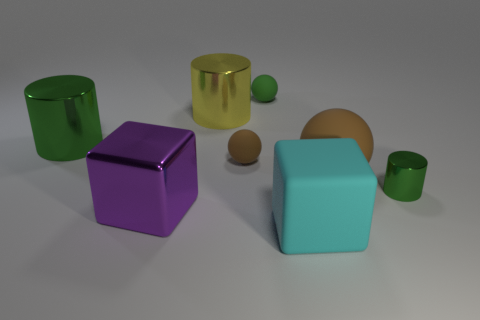Are any tiny purple shiny objects visible?
Give a very brief answer. No. How many tiny rubber spheres are the same color as the large ball?
Keep it short and to the point. 1. Are the large yellow cylinder and the object in front of the big shiny cube made of the same material?
Offer a terse response. No. Are there more green metal things in front of the big brown thing than big cyan cylinders?
Keep it short and to the point. Yes. There is a large rubber sphere; is it the same color as the small sphere that is in front of the large green cylinder?
Ensure brevity in your answer.  Yes. Are there an equal number of big brown balls behind the big brown matte object and green cylinders that are on the left side of the green ball?
Keep it short and to the point. No. There is a cylinder that is right of the big cyan object; what is its material?
Your response must be concise. Metal. What number of things are cylinders that are on the right side of the small brown matte object or cubes?
Make the answer very short. 3. What number of other objects are there of the same shape as the large purple object?
Ensure brevity in your answer.  1. There is a brown object that is to the left of the small green rubber thing; does it have the same shape as the green matte object?
Offer a very short reply. Yes. 